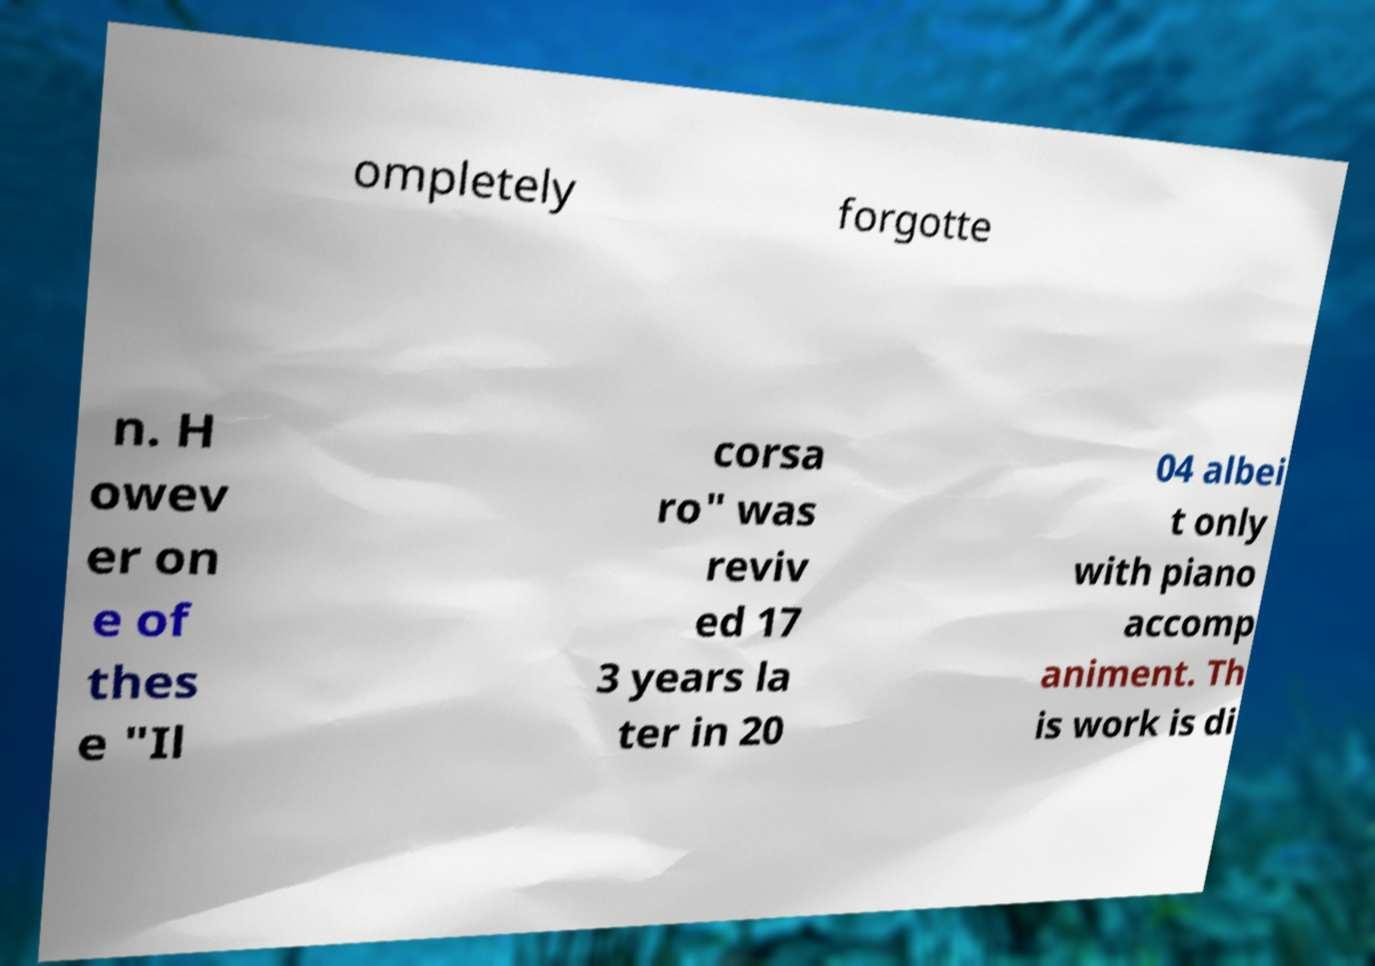Can you accurately transcribe the text from the provided image for me? ompletely forgotte n. H owev er on e of thes e "Il corsa ro" was reviv ed 17 3 years la ter in 20 04 albei t only with piano accomp animent. Th is work is di 